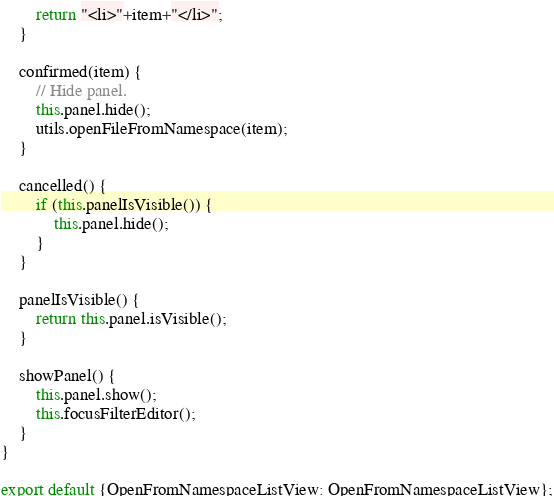Convert code to text. <code><loc_0><loc_0><loc_500><loc_500><_JavaScript_>        return "<li>"+item+"</li>";
    }

    confirmed(item) {
        // Hide panel.
        this.panel.hide();
        utils.openFileFromNamespace(item);
    }

    cancelled() {
        if (this.panelIsVisible()) {
            this.panel.hide();
        }
    }

    panelIsVisible() {
        return this.panel.isVisible();
    }

    showPanel() {
        this.panel.show();
        this.focusFilterEditor();
    }
}

export default {OpenFromNamespaceListView: OpenFromNamespaceListView};
</code> 